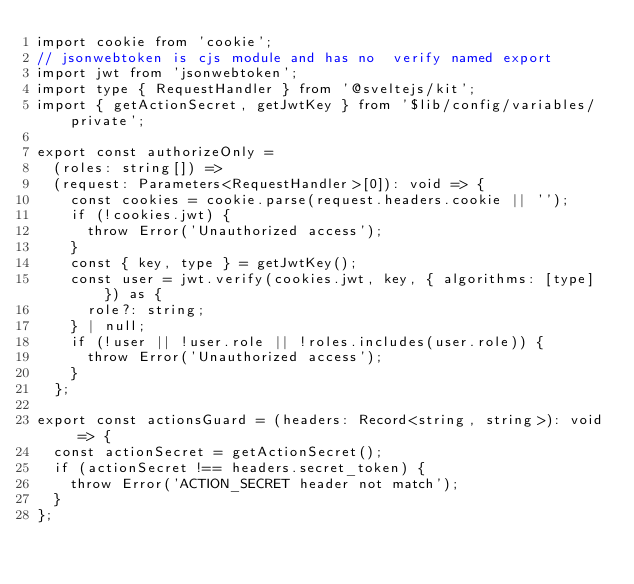Convert code to text. <code><loc_0><loc_0><loc_500><loc_500><_TypeScript_>import cookie from 'cookie';
// jsonwebtoken is cjs module and has no  verify named export
import jwt from 'jsonwebtoken';
import type { RequestHandler } from '@sveltejs/kit';
import { getActionSecret, getJwtKey } from '$lib/config/variables/private';

export const authorizeOnly =
	(roles: string[]) =>
	(request: Parameters<RequestHandler>[0]): void => {
		const cookies = cookie.parse(request.headers.cookie || '');
		if (!cookies.jwt) {
			throw Error('Unauthorized access');
		}
		const { key, type } = getJwtKey();
		const user = jwt.verify(cookies.jwt, key, { algorithms: [type] }) as {
			role?: string;
		} | null;
		if (!user || !user.role || !roles.includes(user.role)) {
			throw Error('Unauthorized access');
		}
	};

export const actionsGuard = (headers: Record<string, string>): void => {
	const actionSecret = getActionSecret();
	if (actionSecret !== headers.secret_token) {
		throw Error('ACTION_SECRET header not match');
	}
};
</code> 